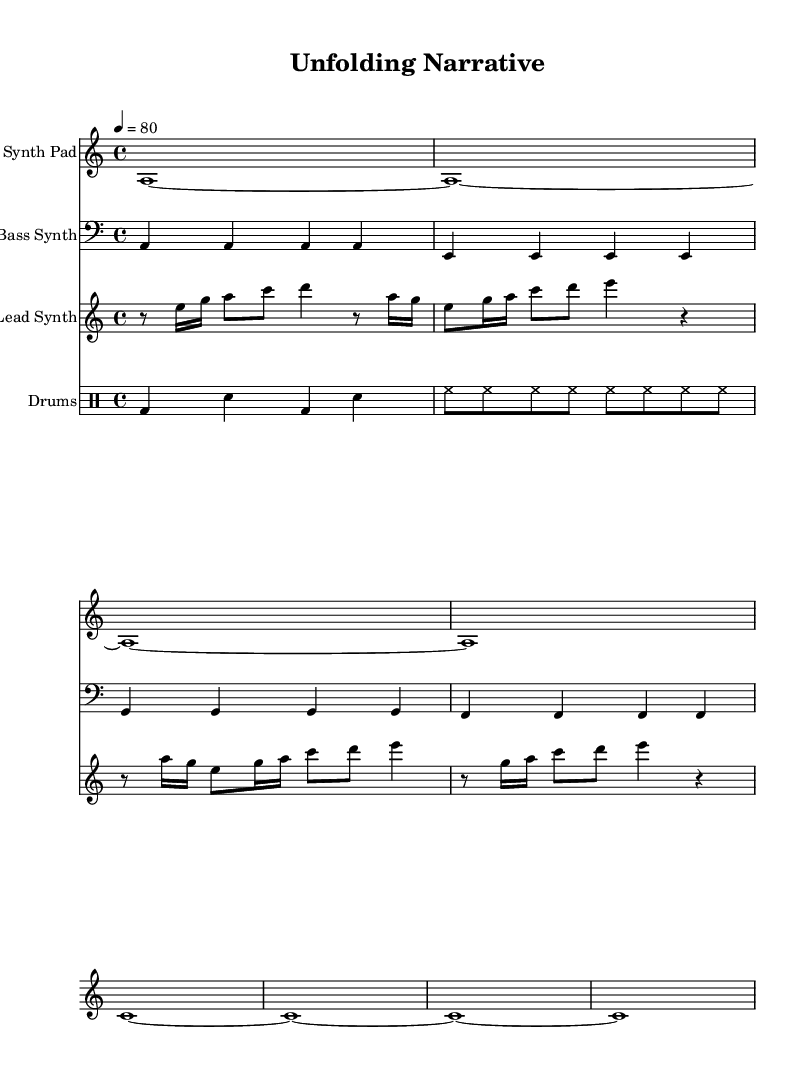What is the key signature of this music? The key signature is a minor, which includes one sharp note, G#, represented on the staff.
Answer: A minor What is the time signature of this music? The time signature is 4/4, indicated by the notation at the beginning, which means there are four beats in a measure.
Answer: 4/4 What is the tempo of this music? The tempo marking shows 80 beats per minute as indicated by "4 = 80," which establishes the pace for playing the piece.
Answer: 80 How many measures does the lead synth part have? Counting the measures in the lead synth staff, there are four measures displayed in total based on the bar lines.
Answer: Four What type of electronic music does this piece represent? Analyzing the combination of downtempo beats and spoken word elements, this piece clearly aligns with the downtempo electronic genre.
Answer: Downtempo electronic What kind of drum pattern is used in this music? The drum part consists of a basic alternating pattern with bass drum and snare, creating a traditional electronic rhythm.
Answer: Alternating bass and snare What element does the spoken word add to the music's narrative? The spoken word brings a narrative quality that enhances the drama and emotional depth of the music, contributing to the storytelling aspect.
Answer: Narrative quality 